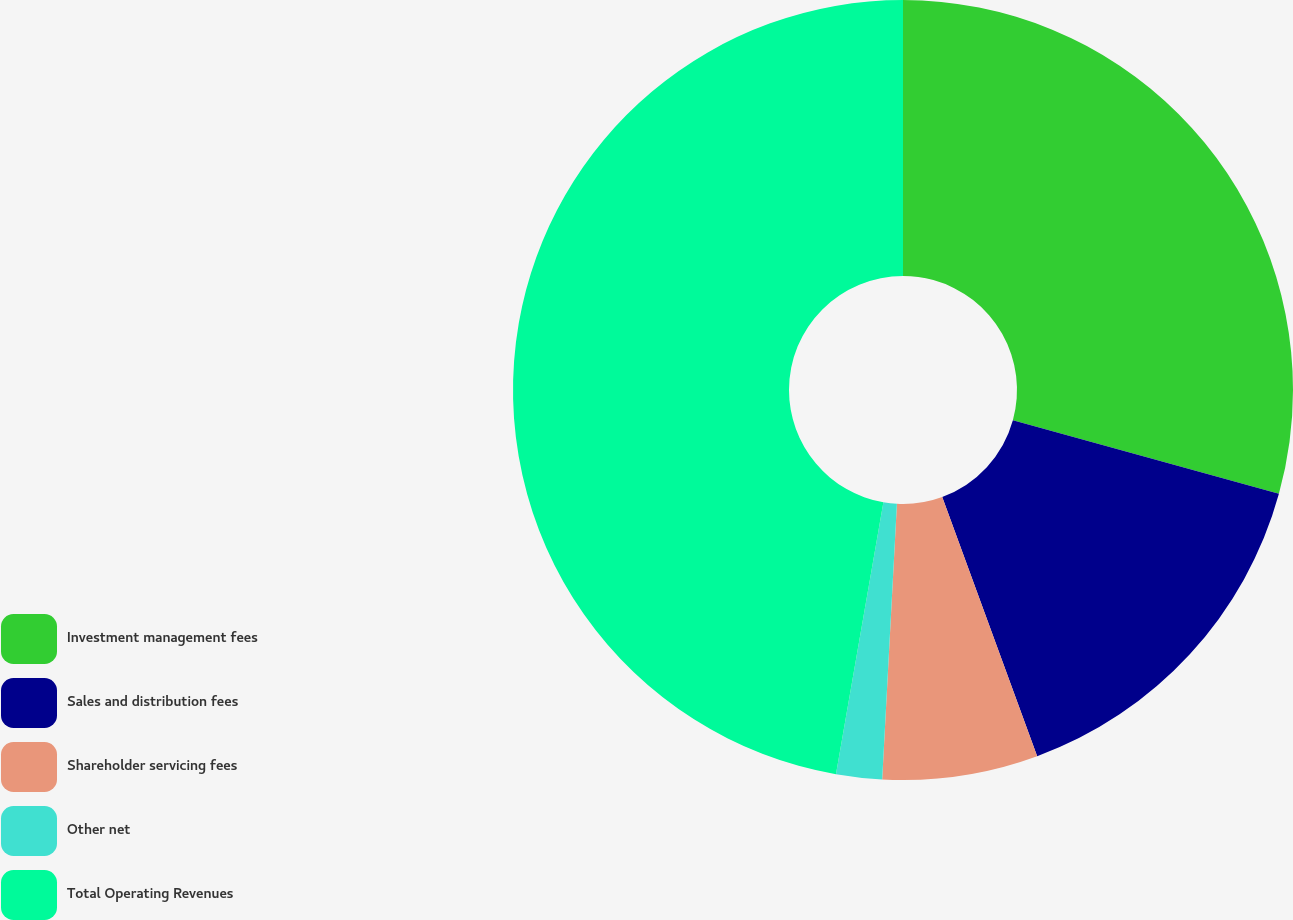Convert chart. <chart><loc_0><loc_0><loc_500><loc_500><pie_chart><fcel>Investment management fees<fcel>Sales and distribution fees<fcel>Shareholder servicing fees<fcel>Other net<fcel>Total Operating Revenues<nl><fcel>29.29%<fcel>15.12%<fcel>6.44%<fcel>1.9%<fcel>47.25%<nl></chart> 